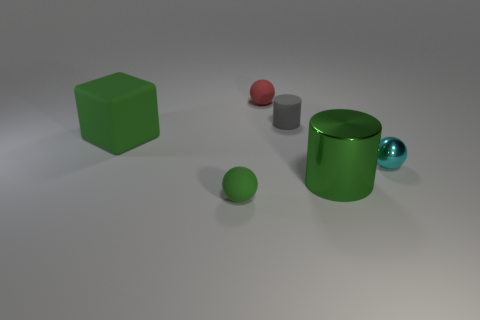What is the size of the ball that is the same color as the metallic cylinder?
Keep it short and to the point. Small. There is a green thing that is right of the large green matte thing and on the left side of the tiny gray matte object; what size is it?
Your response must be concise. Small. What material is the cylinder that is the same color as the large matte object?
Provide a succinct answer. Metal. Do the big object to the left of the tiny red matte ball and the cylinder in front of the gray thing have the same color?
Provide a succinct answer. Yes. Do the cyan object and the rubber block have the same size?
Provide a short and direct response. No. There is a large object that is in front of the small ball to the right of the gray rubber thing; what is its material?
Keep it short and to the point. Metal. There is a cylinder that is in front of the cyan thing; is it the same size as the green object that is behind the big metal cylinder?
Provide a succinct answer. Yes. There is a rubber sphere in front of the big cube; what is its size?
Your answer should be compact. Small. How big is the rubber thing in front of the green thing behind the large green metal cylinder?
Your response must be concise. Small. There is a gray cylinder that is the same size as the cyan shiny object; what material is it?
Your answer should be very brief. Rubber. 